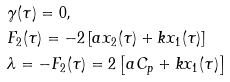Convert formula to latex. <formula><loc_0><loc_0><loc_500><loc_500>& \gamma ( \tau ) = 0 , \\ & F _ { 2 } ( \tau ) = - 2 \left [ a x _ { 2 } ( \tau ) + k x _ { 1 } ( \tau ) \right ] \\ & \lambda = - F _ { 2 } ( \tau ) = 2 \left [ a C _ { p } + k x _ { 1 } ( \tau ) \right ]</formula> 